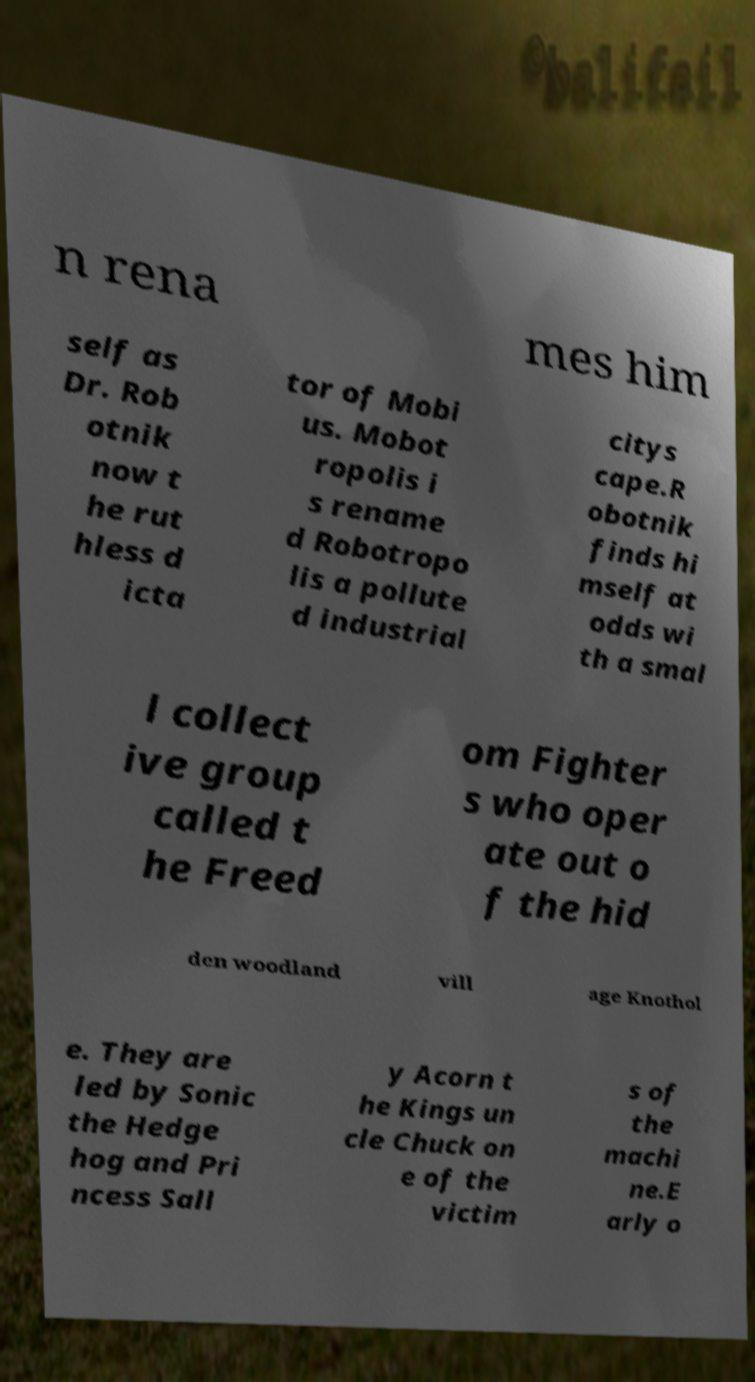Can you read and provide the text displayed in the image?This photo seems to have some interesting text. Can you extract and type it out for me? n rena mes him self as Dr. Rob otnik now t he rut hless d icta tor of Mobi us. Mobot ropolis i s rename d Robotropo lis a pollute d industrial citys cape.R obotnik finds hi mself at odds wi th a smal l collect ive group called t he Freed om Fighter s who oper ate out o f the hid den woodland vill age Knothol e. They are led by Sonic the Hedge hog and Pri ncess Sall y Acorn t he Kings un cle Chuck on e of the victim s of the machi ne.E arly o 